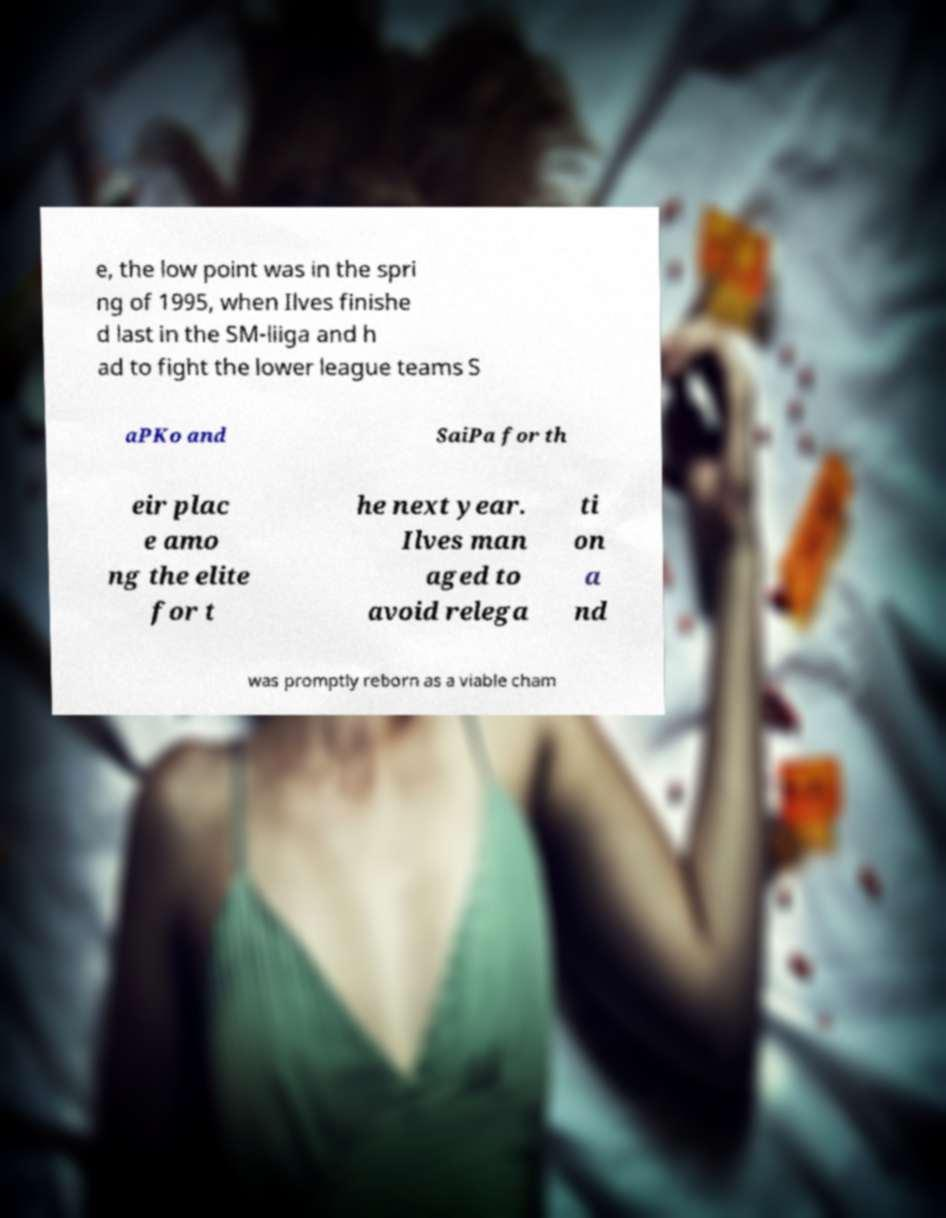Could you extract and type out the text from this image? e, the low point was in the spri ng of 1995, when Ilves finishe d last in the SM-liiga and h ad to fight the lower league teams S aPKo and SaiPa for th eir plac e amo ng the elite for t he next year. Ilves man aged to avoid relega ti on a nd was promptly reborn as a viable cham 